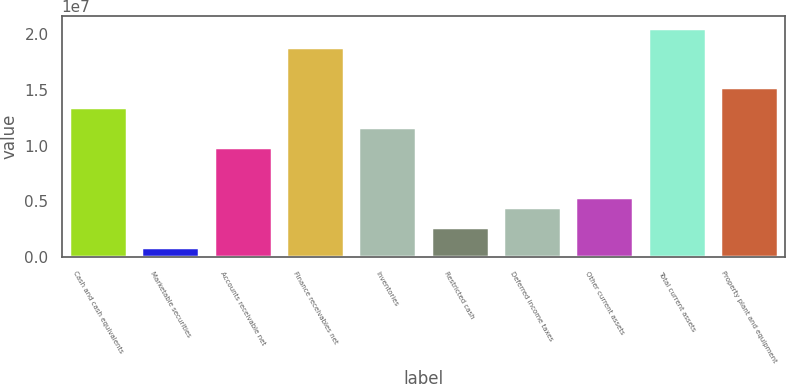Convert chart to OTSL. <chart><loc_0><loc_0><loc_500><loc_500><bar_chart><fcel>Cash and cash equivalents<fcel>Marketable securities<fcel>Accounts receivable net<fcel>Finance receivables net<fcel>Inventories<fcel>Restricted cash<fcel>Deferred income taxes<fcel>Other current assets<fcel>Total current assets<fcel>Property plant and equipment<nl><fcel>1.34413e+07<fcel>899303<fcel>9.85784e+06<fcel>1.88164e+07<fcel>1.16495e+07<fcel>2.69101e+06<fcel>4.48272e+06<fcel>5.37857e+06<fcel>2.06081e+07<fcel>1.5233e+07<nl></chart> 